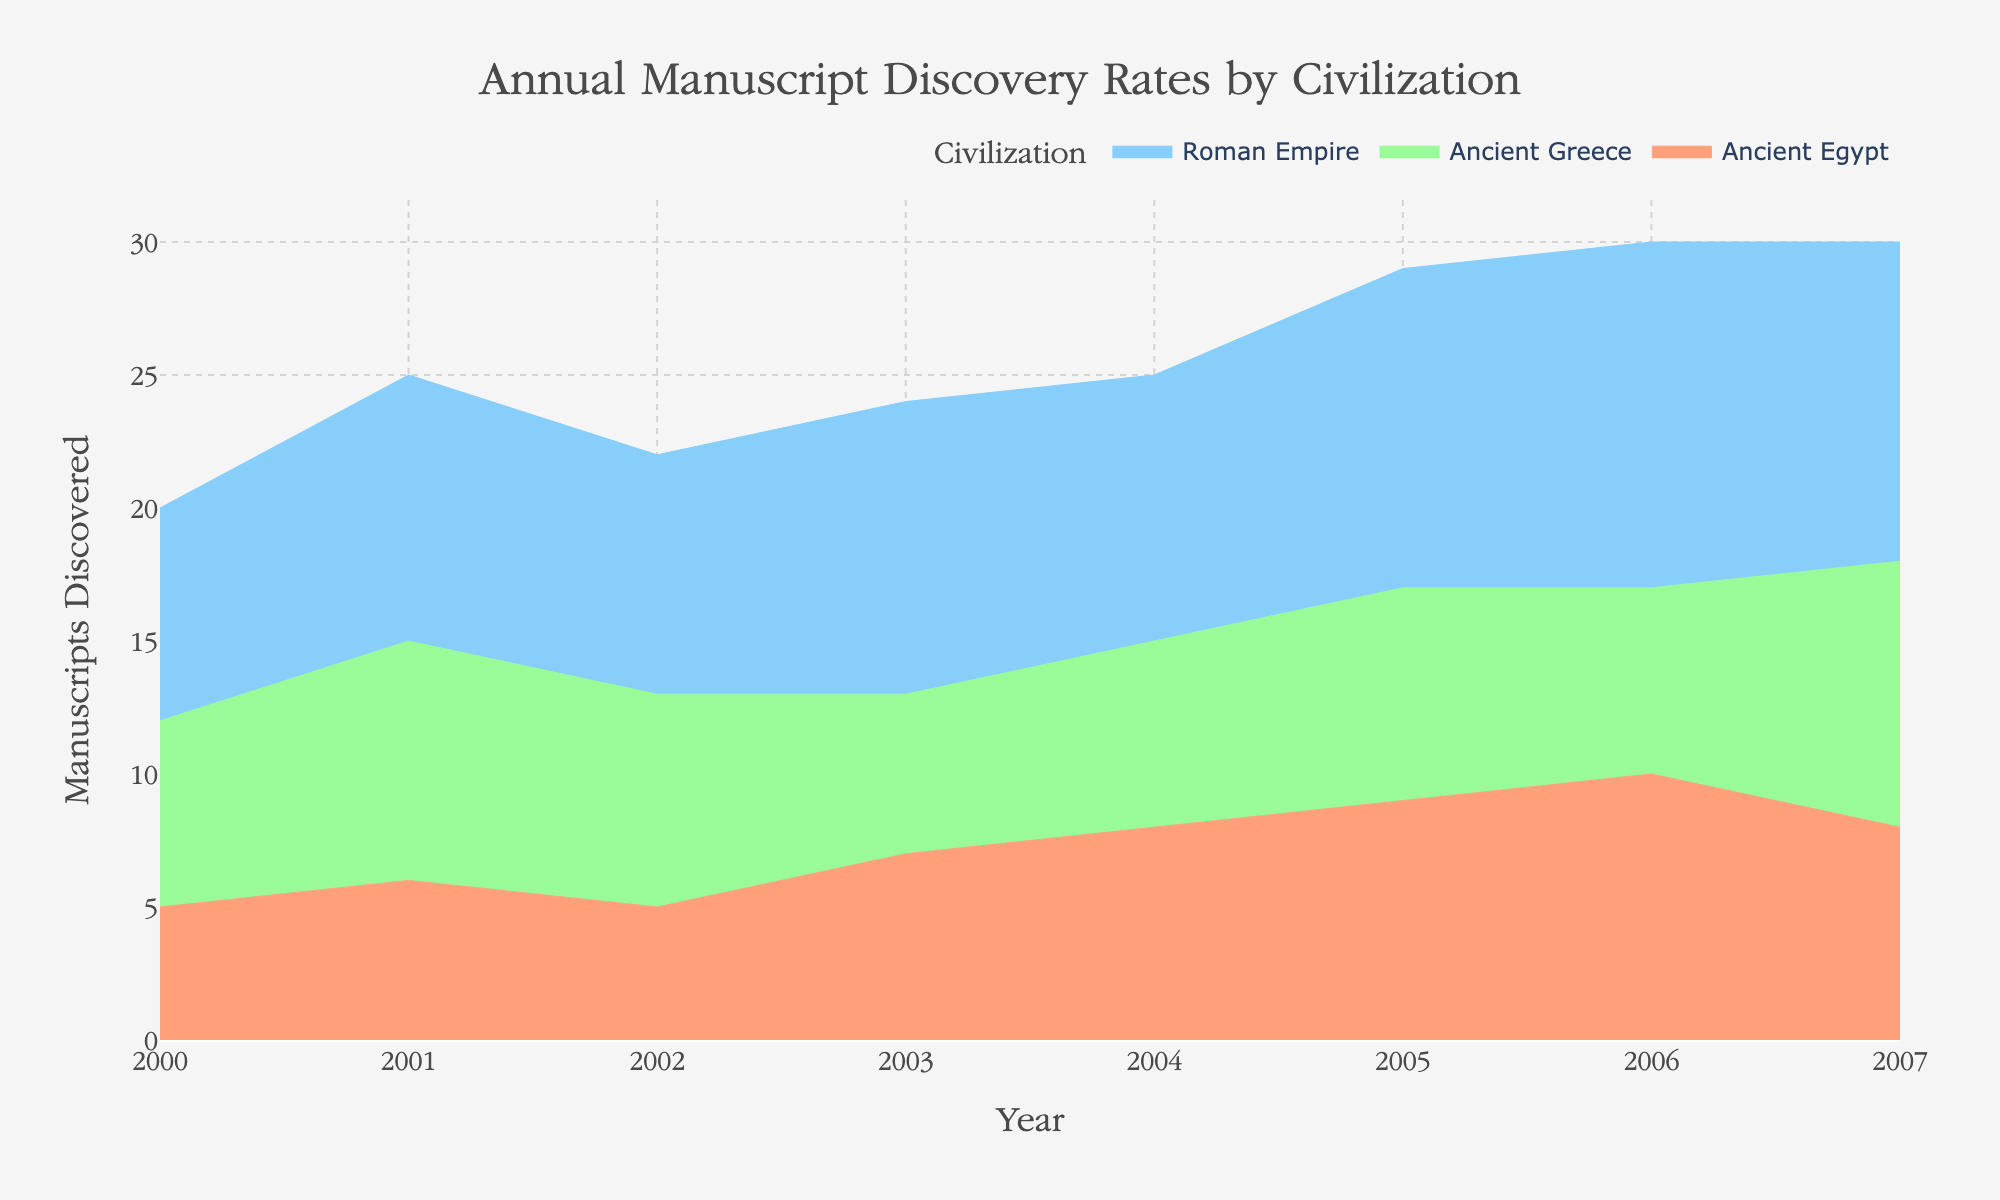what's the title of the area chart? The title usually appears at the top of the chart and summarizes the chart's subject. Here, the title is "Annual Manuscript Discovery Rates by Civilization".
Answer: Annual Manuscript Discovery Rates by Civilization how many civilizations are represented in the figure? From the legend or the colored sections in the area chart, we can count three distinct categories: "Ancient Egypt", "Ancient Greece", and "Roman Empire".
Answer: 3 which year had the highest total number of manuscripts discovered? By visually inspecting the chart, we can see that the combined height of all areas is greatest in the year 2006, indicating the highest total number of manuscripts.
Answer: 2006 what was the discovery rate for Ancient Greece in 2007? By isolating the portion of the area chart corresponding to Ancient Greece for the year 2007, we can see that it is marked at 10 manuscripts discovered.
Answer: 10 compare the manuscript discovery rates of Ancient Egypt and Roman Empire in 2003 From the chart, the height between 2002 and 2004 for both civilizations can be clearly observed. In 2003, Ancient Egypt discovered 7 manuscripts, while the Roman Empire discovered 11 manuscripts.
Answer: Ancient Egypt: 7, Roman Empire: 11 did any civilization experience a decrease in manuscript discovery rate in 2003 compared to 2002? By following the lines on the chart for each civilization, we can see that for Ancient Greece, the rate decreased from 8 in 2002 to 6 in 2003.
Answer: Ancient Greece what is the combined discovery rate for Ancient Egypt and Ancient Greece in 2001? From the chart, sum the number of manuscripts for these civilizations in 2001: 6 (Ancient Egypt) + 9 (Ancient Greece) = 15 manuscripts discovered.
Answer: 15 which civilization had the most consistent discovery rate throughout the years? Observing the chart, the Roman Empire exhibits a steady increase each year without a significant drop, indicating the most consistent discovery trend.
Answer: Roman Empire what trend do you observe for Ancient Greece's manuscript discovery rates from 2004 to 2007? By examining the chart for these years, we notice an initial slight increase from 7 in 2004 to 8 in 2005, then a decrease to 7 in 2006, followed by a notable increase to 10 in 2007.
Answer: Increase, decrease, then significant increase how did the manuscript discovery rate for the Roman Empire change from 2005 to 2006? By inspecting the chart for these specific years, we see the Roman Empire's discovery rate rose from 12 manuscripts in 2005 to 13 manuscripts in 2006, indicating an increase.
Answer: Increased by 1 